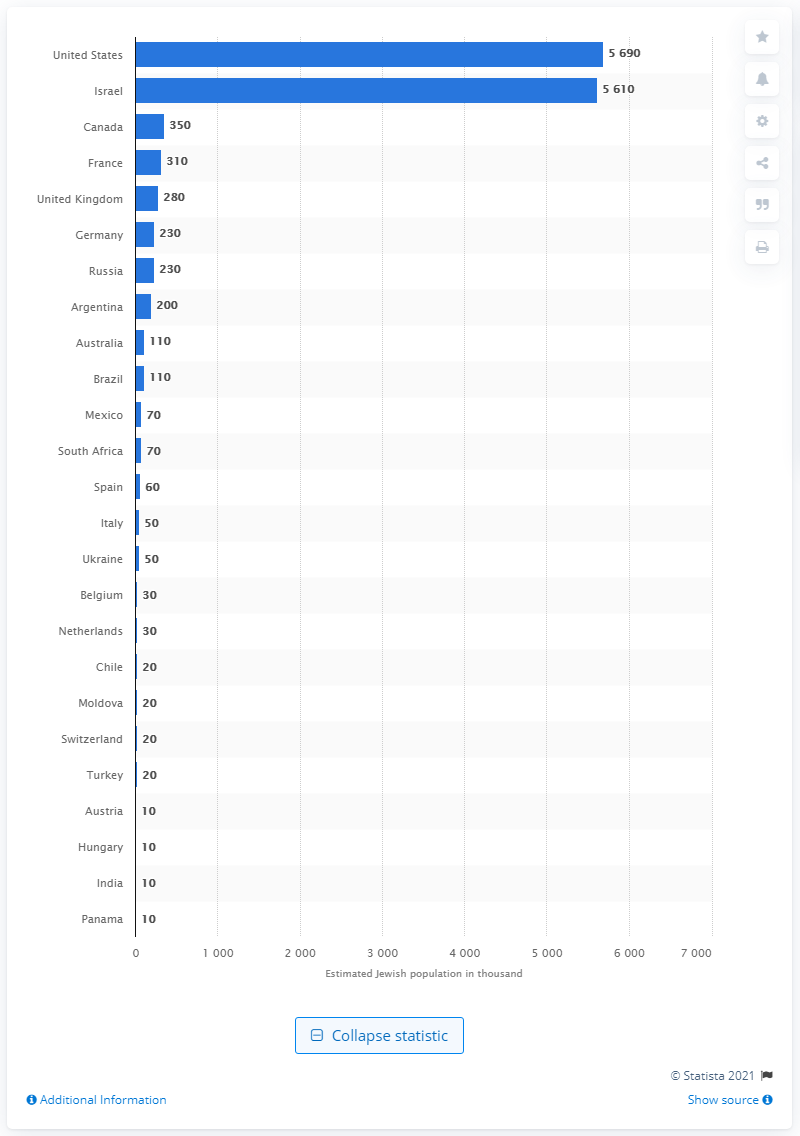Specify some key components in this picture. In 2010, it is estimated that approximately 5,690 Jews resided in the United States. 